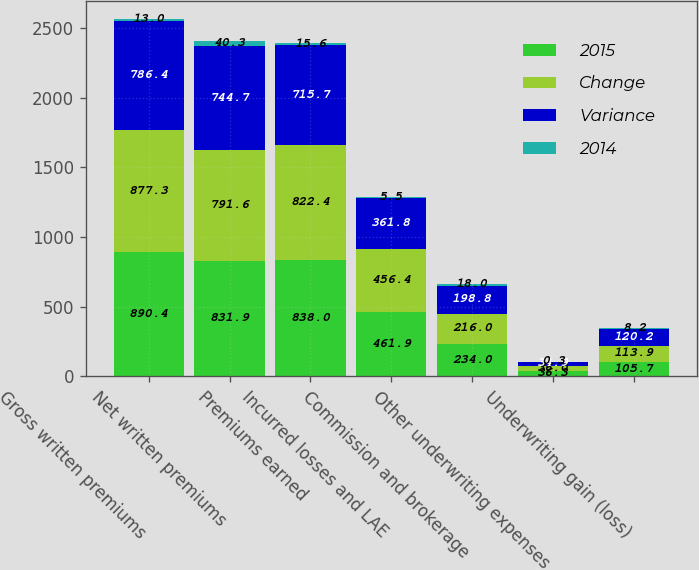Convert chart. <chart><loc_0><loc_0><loc_500><loc_500><stacked_bar_chart><ecel><fcel>Gross written premiums<fcel>Net written premiums<fcel>Premiums earned<fcel>Incurred losses and LAE<fcel>Commission and brokerage<fcel>Other underwriting expenses<fcel>Underwriting gain (loss)<nl><fcel>2015<fcel>890.4<fcel>831.9<fcel>838<fcel>461.9<fcel>234<fcel>36.3<fcel>105.7<nl><fcel>Change<fcel>877.3<fcel>791.6<fcel>822.4<fcel>456.4<fcel>216<fcel>36<fcel>113.9<nl><fcel>Variance<fcel>786.4<fcel>744.7<fcel>715.7<fcel>361.8<fcel>198.8<fcel>34.9<fcel>120.2<nl><fcel>2014<fcel>13<fcel>40.3<fcel>15.6<fcel>5.5<fcel>18<fcel>0.3<fcel>8.2<nl></chart> 